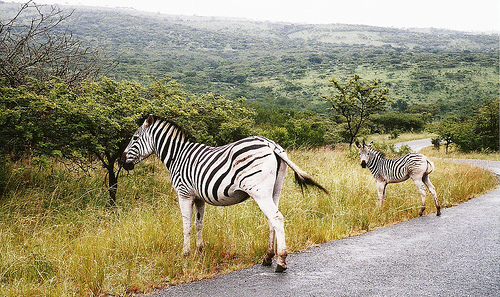<image>
Is there a green tree behind the baby zebra? Yes. From this viewpoint, the green tree is positioned behind the baby zebra, with the baby zebra partially or fully occluding the green tree. Where is the zebra in relation to the grass? Is it behind the grass? No. The zebra is not behind the grass. From this viewpoint, the zebra appears to be positioned elsewhere in the scene. 